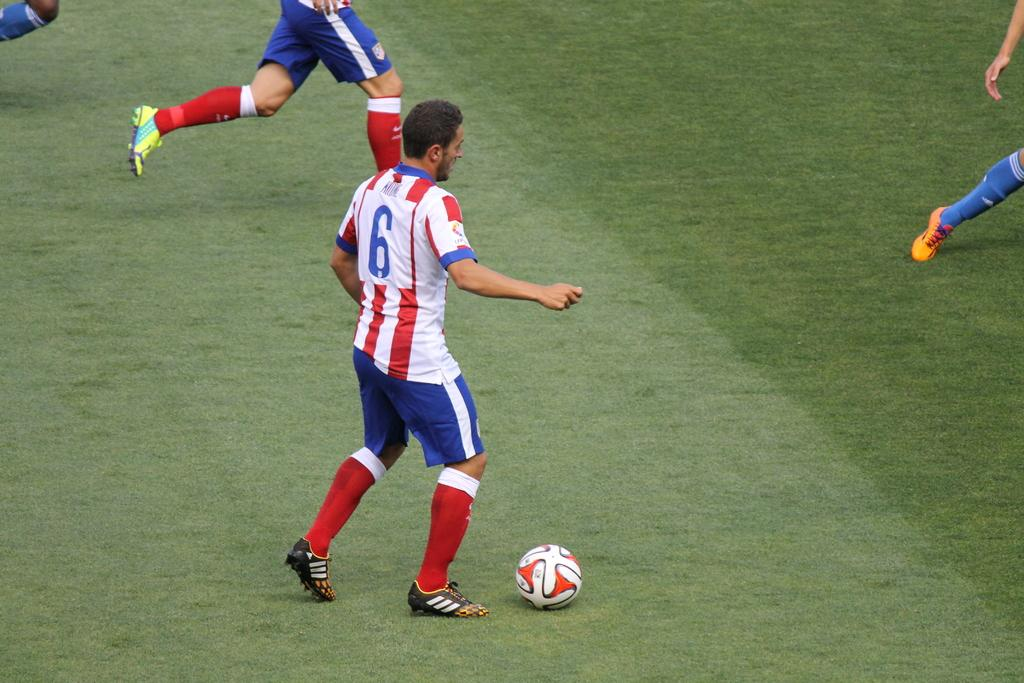<image>
Describe the image concisely. Soccer player ready to kick the ball, wearing Red, White, and Blue colors, he is #6 on the field. 